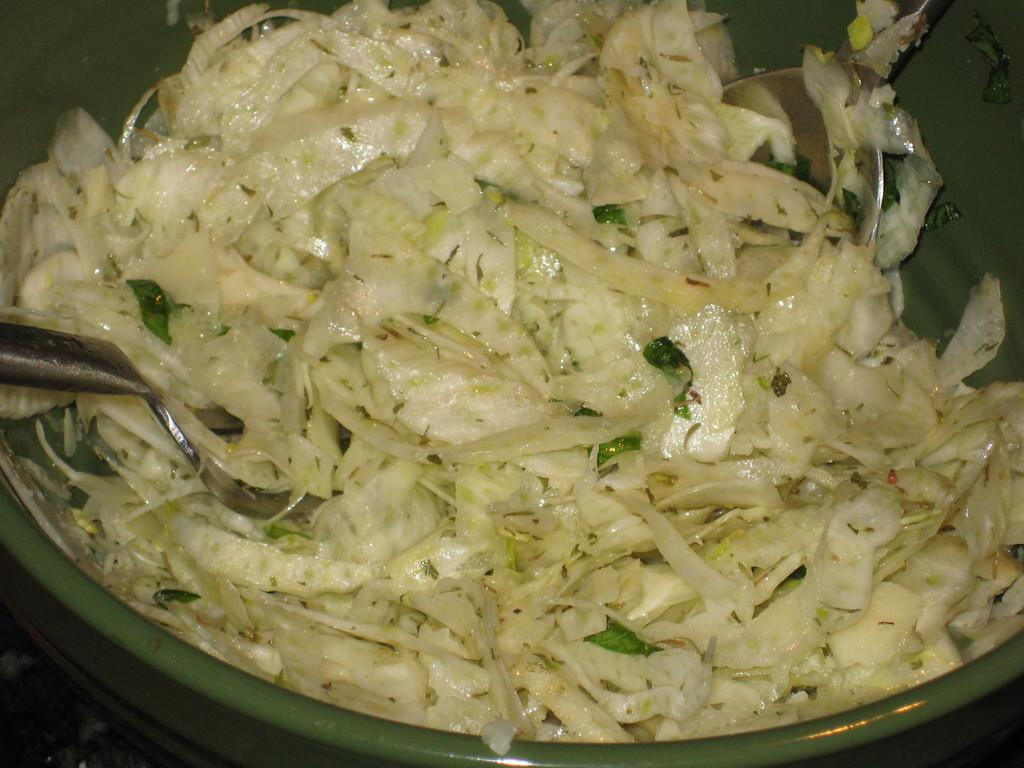What color is the bowl in the image? The bowl in the image is green. What can be seen inside the green bowl? There is food in the image that is white and green in color. How many spoons are visible in the image? There are 2 silver-colored spoons in the image. What type of machine is being used to attack the food in the image? There is no machine or attack present in the image; it simply shows a green bowl with food and spoons. 